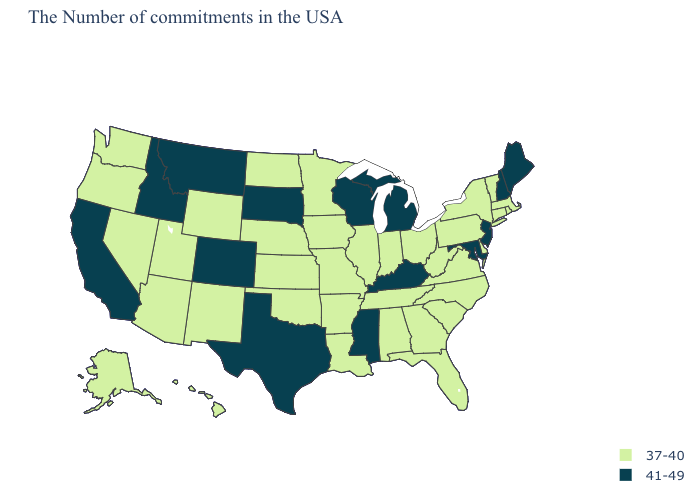Among the states that border Vermont , does Massachusetts have the highest value?
Be succinct. No. Name the states that have a value in the range 37-40?
Write a very short answer. Massachusetts, Rhode Island, Vermont, Connecticut, New York, Delaware, Pennsylvania, Virginia, North Carolina, South Carolina, West Virginia, Ohio, Florida, Georgia, Indiana, Alabama, Tennessee, Illinois, Louisiana, Missouri, Arkansas, Minnesota, Iowa, Kansas, Nebraska, Oklahoma, North Dakota, Wyoming, New Mexico, Utah, Arizona, Nevada, Washington, Oregon, Alaska, Hawaii. Does the first symbol in the legend represent the smallest category?
Quick response, please. Yes. Name the states that have a value in the range 37-40?
Give a very brief answer. Massachusetts, Rhode Island, Vermont, Connecticut, New York, Delaware, Pennsylvania, Virginia, North Carolina, South Carolina, West Virginia, Ohio, Florida, Georgia, Indiana, Alabama, Tennessee, Illinois, Louisiana, Missouri, Arkansas, Minnesota, Iowa, Kansas, Nebraska, Oklahoma, North Dakota, Wyoming, New Mexico, Utah, Arizona, Nevada, Washington, Oregon, Alaska, Hawaii. Does Texas have the same value as Indiana?
Quick response, please. No. Does Nevada have the same value as Washington?
Answer briefly. Yes. What is the lowest value in the USA?
Give a very brief answer. 37-40. What is the value of Rhode Island?
Short answer required. 37-40. What is the highest value in the MidWest ?
Give a very brief answer. 41-49. Name the states that have a value in the range 41-49?
Keep it brief. Maine, New Hampshire, New Jersey, Maryland, Michigan, Kentucky, Wisconsin, Mississippi, Texas, South Dakota, Colorado, Montana, Idaho, California. Does Louisiana have the highest value in the South?
Short answer required. No. What is the highest value in the USA?
Give a very brief answer. 41-49. Does Maryland have the highest value in the South?
Write a very short answer. Yes. Does Texas have the highest value in the South?
Give a very brief answer. Yes. Which states have the lowest value in the USA?
Give a very brief answer. Massachusetts, Rhode Island, Vermont, Connecticut, New York, Delaware, Pennsylvania, Virginia, North Carolina, South Carolina, West Virginia, Ohio, Florida, Georgia, Indiana, Alabama, Tennessee, Illinois, Louisiana, Missouri, Arkansas, Minnesota, Iowa, Kansas, Nebraska, Oklahoma, North Dakota, Wyoming, New Mexico, Utah, Arizona, Nevada, Washington, Oregon, Alaska, Hawaii. 